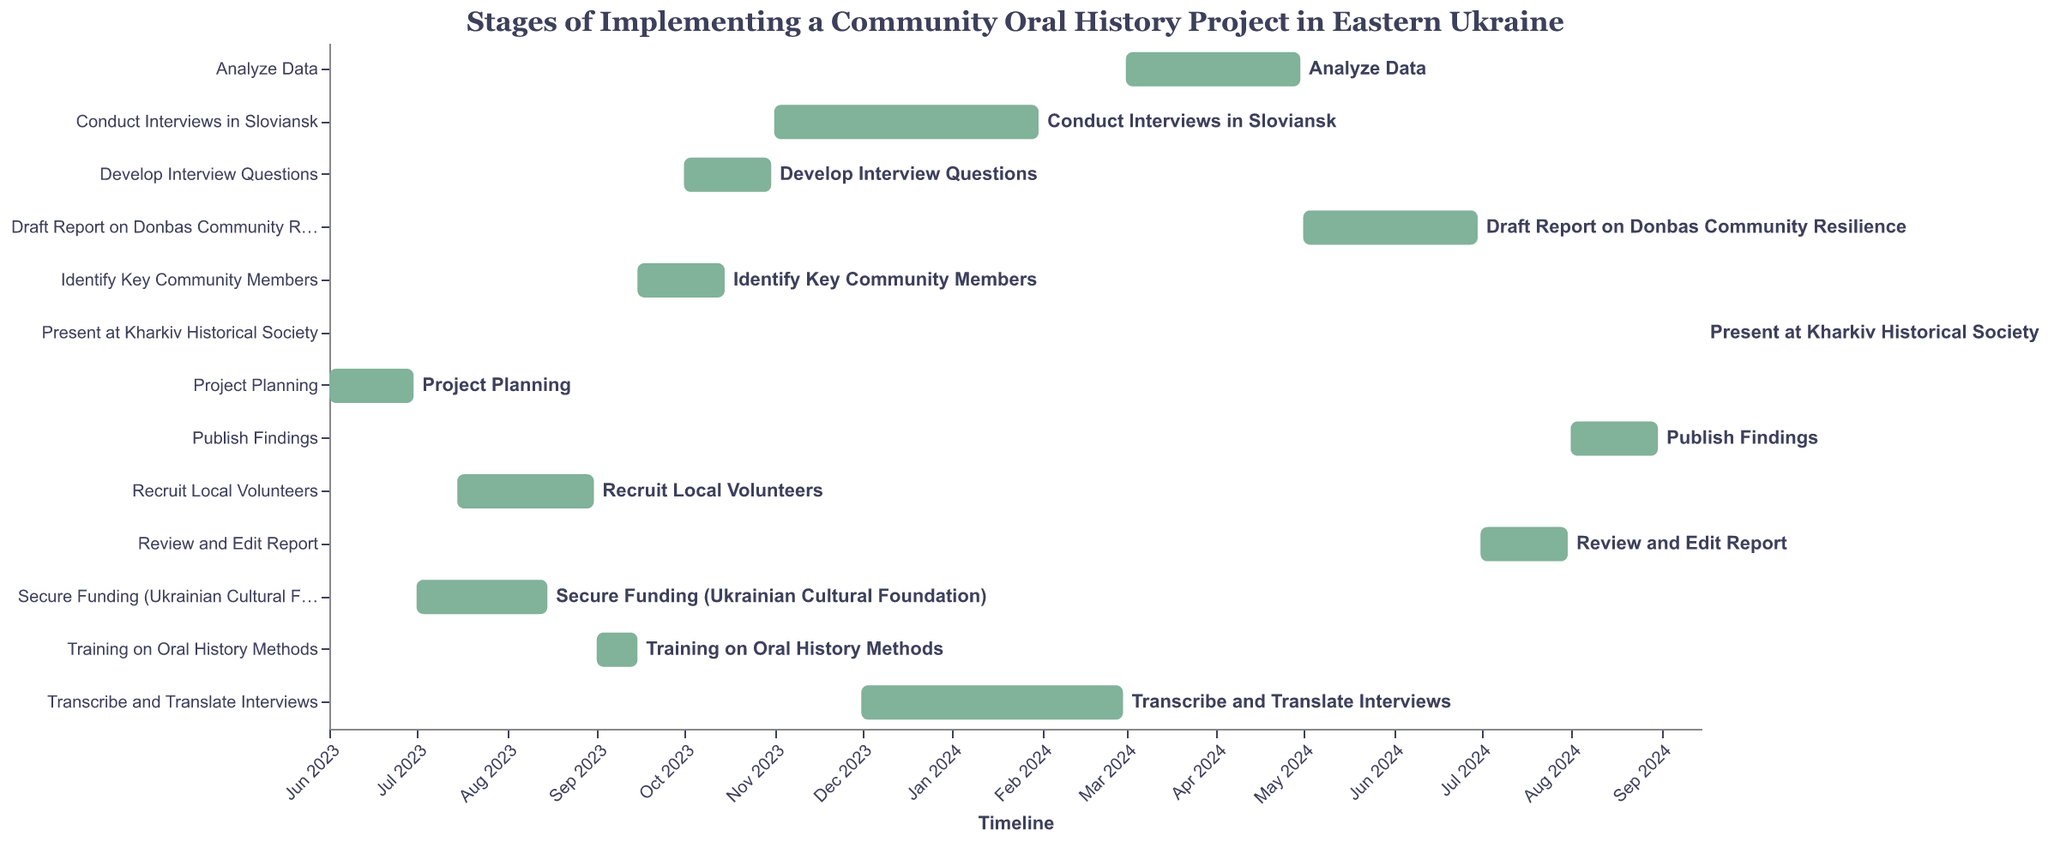When does the Transcribe and Translate Interviews task start and end? The figure shows the timeline for each task. For "Transcribe and Translate Interviews," it starts on "2023-12-01" and ends on "2024-02-29."
Answer: 2023-12-01 to 2024-02-29 Which task is the longest in duration? By comparing the start and end dates, the "Conduct Interviews in Sloviansk" task spans from "2023-11-01" to "2024-01-31," making it the longest.
Answer: Conduct Interviews in Sloviansk What is the duration of the Secure Funding task? The Secure Funding task starts on "2023-07-01" and ends on "2023-08-15." Calculating the duration, it lasts for 46 days.
Answer: 46 days Which tasks overlap in September 2023? The figure shows the tasks and their timelines. In September 2023, "Training on Oral History Methods" and "Identify Key Community Members" overlap, with dates from "2023-09-01" to "2023-09-15" and "2023-09-15" to "2023-10-15," respectively.
Answer: Training on Oral History Methods and Identify Key Community Members How many tasks are completed by the end of 2023? Analyzing the figure, tasks completed before or on the end date of 2023 are: "Project Planning," "Secure Funding," "Recruit Local Volunteers," "Training on Oral History Methods," "Identify Key Community Members," and "Develop Interview Questions." This sums up to six tasks.
Answer: 6 tasks Which task starts immediately after the 'Analyze Data' task ends? The "Analyze Data" task ends on "2024-04-30." The next task, "Draft Report on Donbas Community Resilience," starts on "2024-05-01."
Answer: Draft Report on Donbas Community Resilience What is the total project duration from start to the presentation? The project starts on "2023-06-01" and ends with the "Present at Kharkiv Historical Society" on "2024-09-15." Therefore, the total duration is from June 2023 to mid-September 2024.
Answer: June 2023 to mid-September 2024 Which tasks have the same end date? According to the figure, "Training on Oral History Methods" and "Identify Key Community Members" both end on "2023-09-15."
Answer: Training on Oral History Methods and Identify Key Community Members 